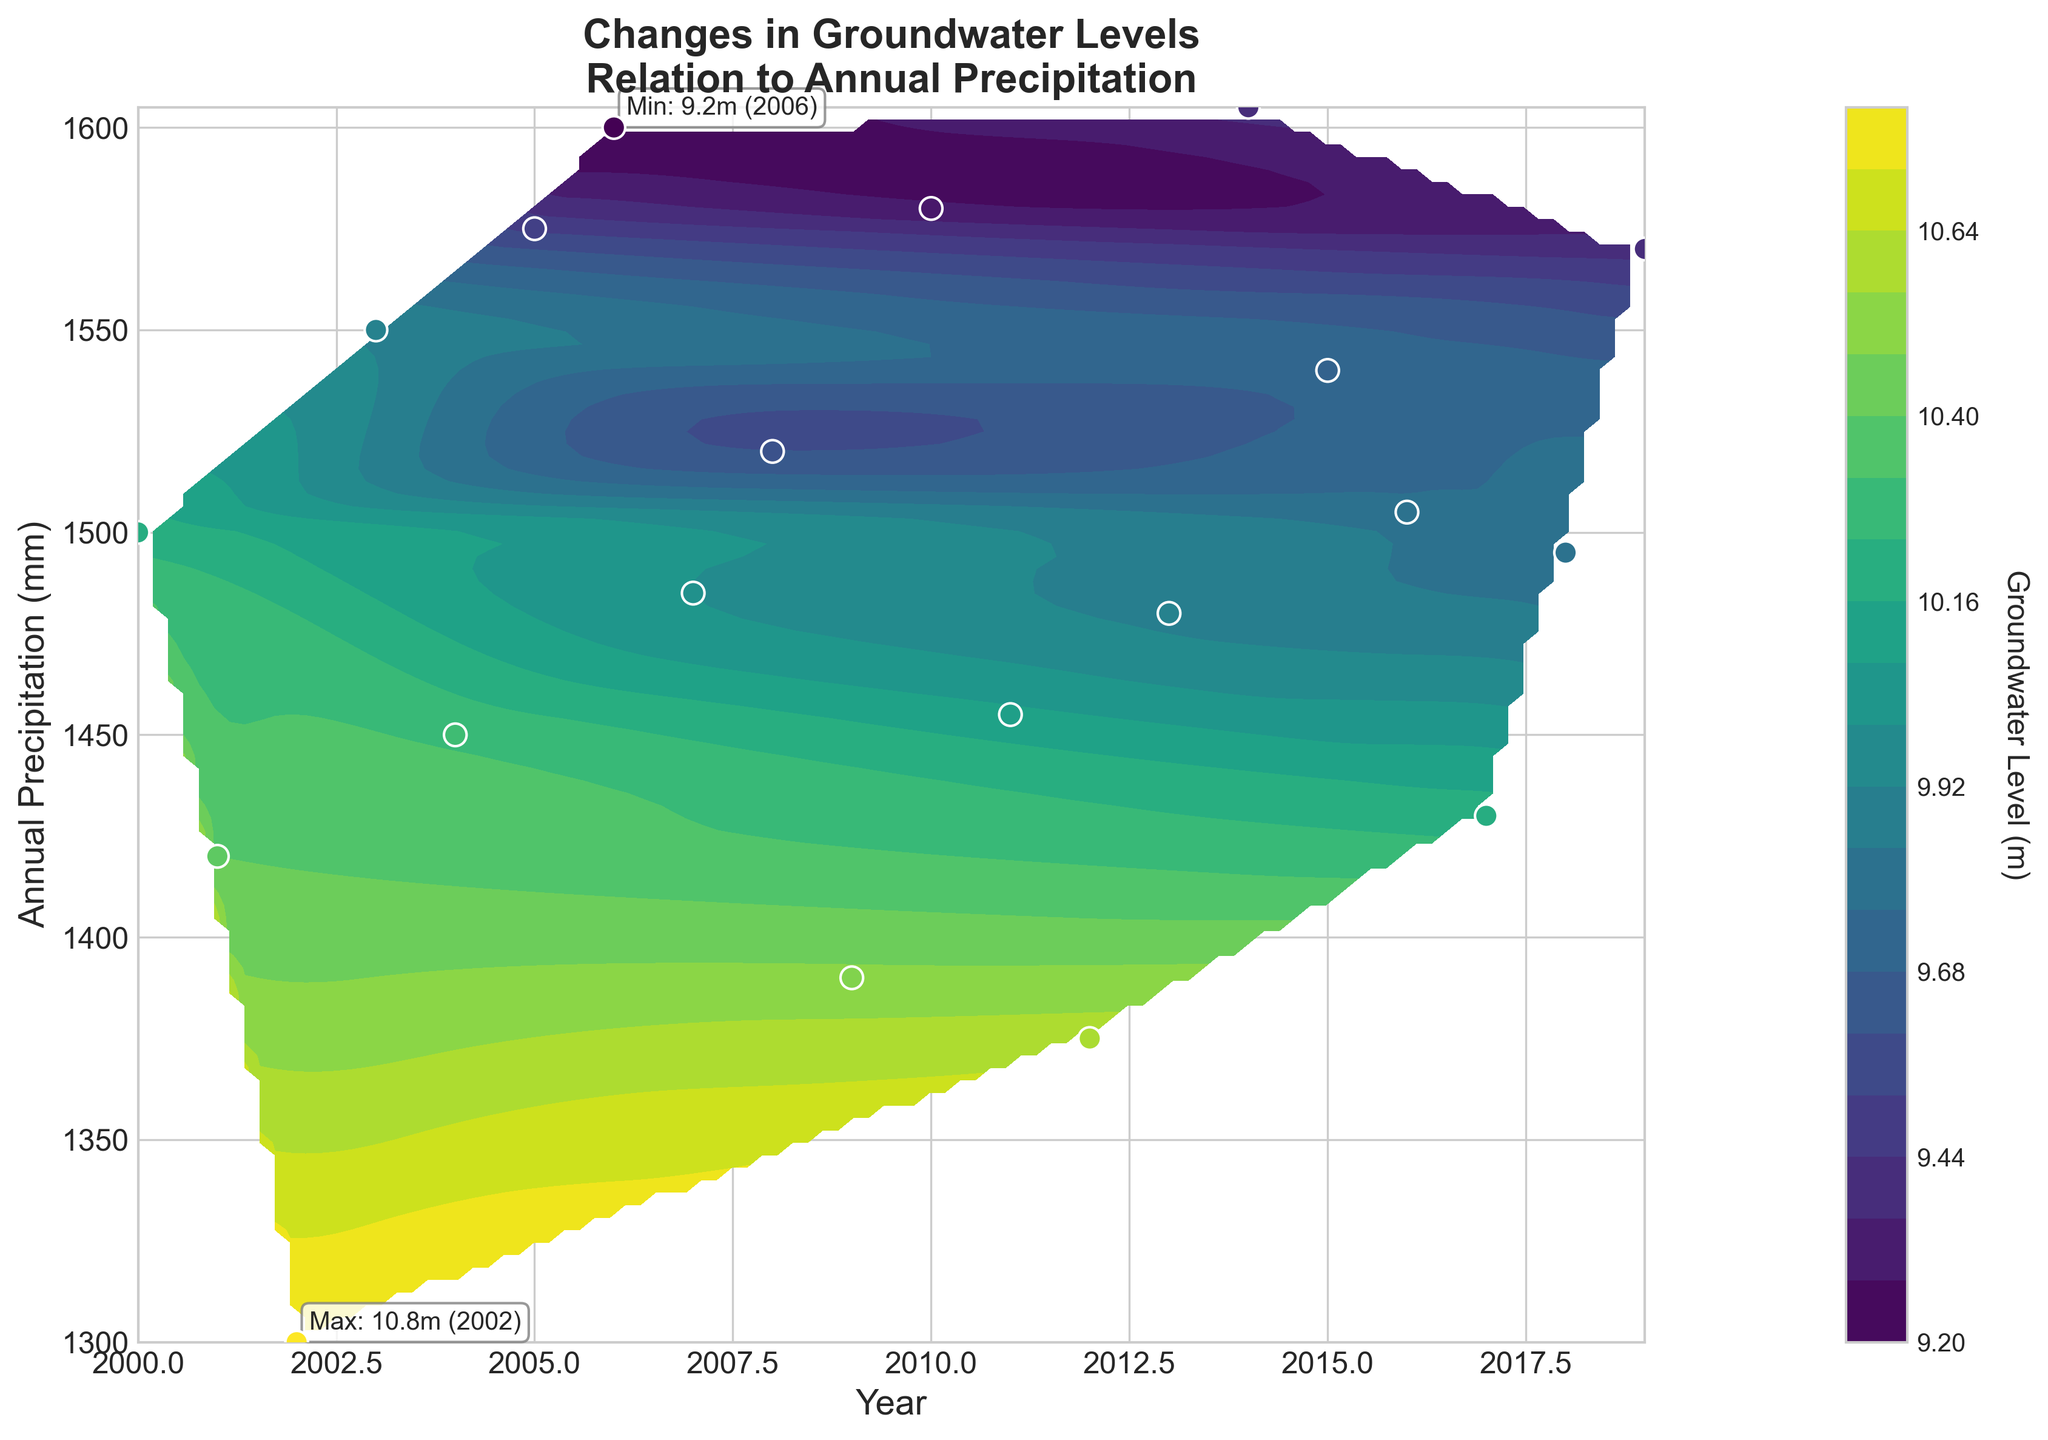What is the title of the figure? The title is usually located at the top of the figure, providing a general description of what the plot represents. In this case, based on the provided code, the title should be clearly readable.
Answer: Changes in Groundwater Levels in Relation to Annual Precipitation What do the colors in the contour plot represent? The colors in the contour plot correspond to different groundwater levels (in meters). This information is indicated by the color bar on the side of the plot.
Answer: Groundwater Level (m) Which year had the highest groundwater level, and what was its value? The annotated text on the figure highlights the maximum groundwater level with its corresponding year. According to the code, this should be marked clearly on the plot.
Answer: 2002, 10.8m How does the groundwater level change with increasing precipitation? By observing the color patterns and contour lines, we can infer the general trend of how groundwater levels are affected by annual precipitation levels. Generally, regions with lower precipitation have higher groundwater levels, and regions with higher precipitation have lower groundwater levels.
Answer: Groundwater level decreases with increasing precipitation What was the annual precipitation in the year with the minimum groundwater level? The annotated text on the figure highlights the minimum groundwater level with its corresponding year. We can then look at the precipitation value for that specific year on the x-axis.
Answer: 1600 mm (2006) Compare the groundwater levels in 2005 and 2010. Which year had a lower level? By comparing the positions on the contour plot corresponding to these two years, and potentially also examining the scatter points, we can determine which year had a lower groundwater level. According to the data:
Answer: 2010 (9.3m) had a lower level than 2005 (9.5m) What is the range of precipitation values shown on the y-axis? By observing the y-axis, we can determine the minimum and maximum values of annual precipitation shown in the figure. This range is indicated by the tick marks along the y-axis.
Answer: 1300 mm to 1605 mm How many data points are there in the plot? By observing the scatter points (marked by circles) on the contour plot, we can count the total number of data points representing the years and their corresponding precipitation levels. According to the provided data, we can also verify this count directly.
Answer: 20 What is the general trend of groundwater levels from 2000 to 2019, regardless of precipitation? By following the contour plot from left to right (which corresponds to the timeline from 2000 to 2019) and observing the color gradient, we can infer the overall trend of groundwater levels over the years.
Answer: Decreasing trend 